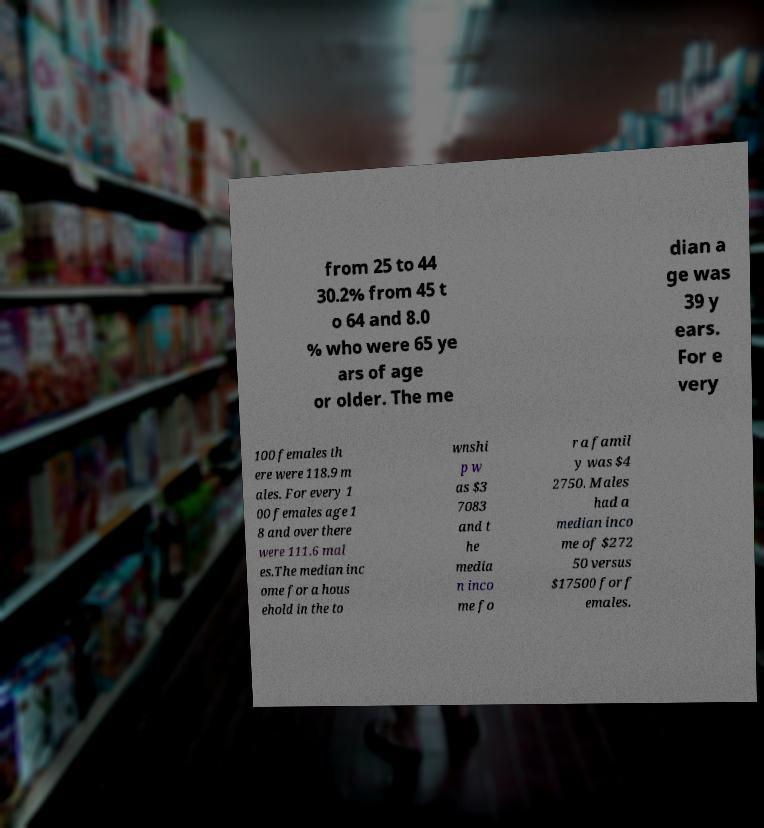Could you extract and type out the text from this image? from 25 to 44 30.2% from 45 t o 64 and 8.0 % who were 65 ye ars of age or older. The me dian a ge was 39 y ears. For e very 100 females th ere were 118.9 m ales. For every 1 00 females age 1 8 and over there were 111.6 mal es.The median inc ome for a hous ehold in the to wnshi p w as $3 7083 and t he media n inco me fo r a famil y was $4 2750. Males had a median inco me of $272 50 versus $17500 for f emales. 